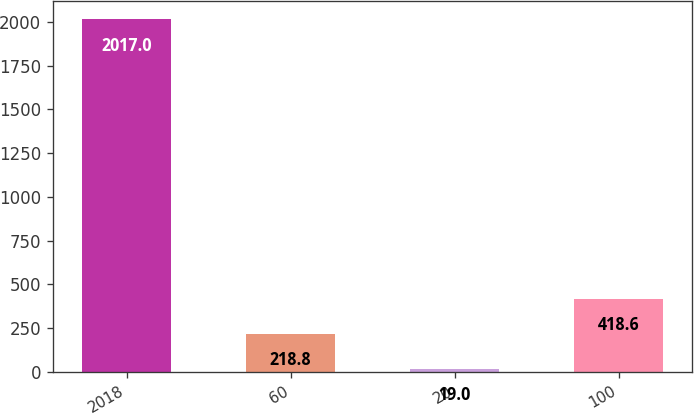Convert chart to OTSL. <chart><loc_0><loc_0><loc_500><loc_500><bar_chart><fcel>2018<fcel>60<fcel>20<fcel>100<nl><fcel>2017<fcel>218.8<fcel>19<fcel>418.6<nl></chart> 